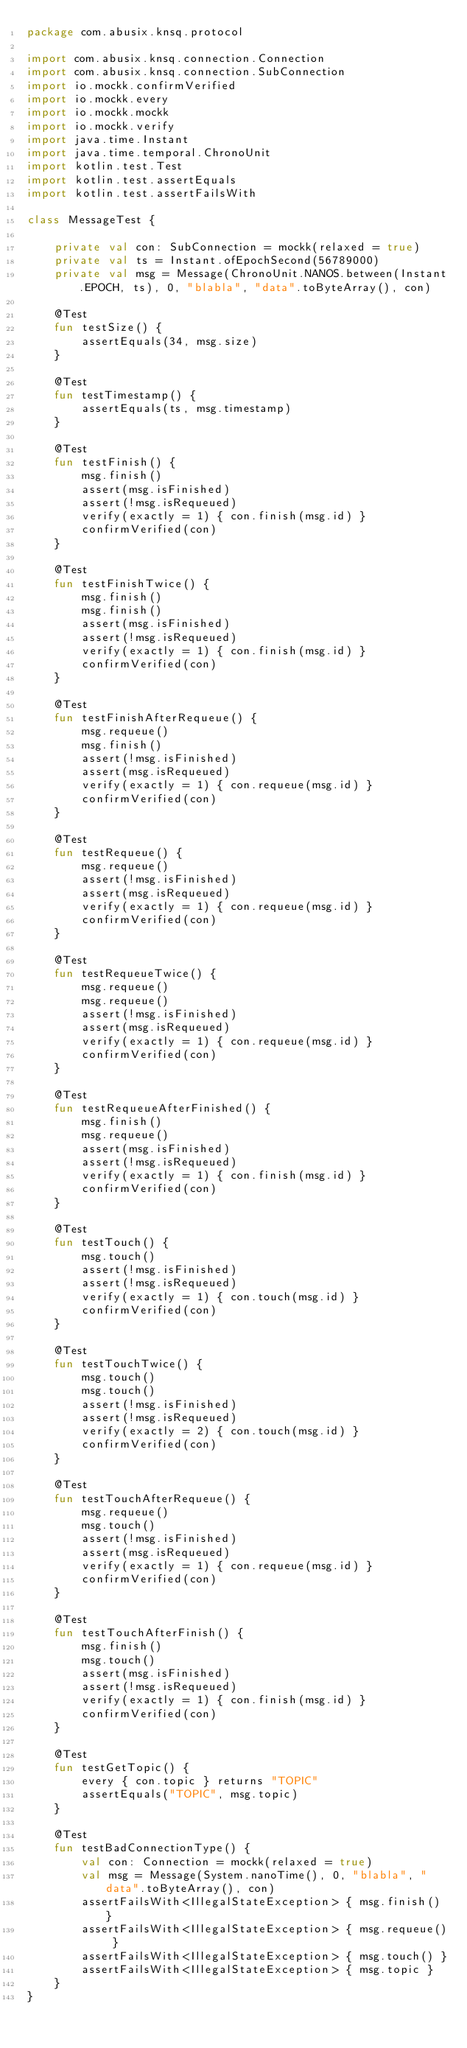Convert code to text. <code><loc_0><loc_0><loc_500><loc_500><_Kotlin_>package com.abusix.knsq.protocol

import com.abusix.knsq.connection.Connection
import com.abusix.knsq.connection.SubConnection
import io.mockk.confirmVerified
import io.mockk.every
import io.mockk.mockk
import io.mockk.verify
import java.time.Instant
import java.time.temporal.ChronoUnit
import kotlin.test.Test
import kotlin.test.assertEquals
import kotlin.test.assertFailsWith

class MessageTest {

    private val con: SubConnection = mockk(relaxed = true)
    private val ts = Instant.ofEpochSecond(56789000)
    private val msg = Message(ChronoUnit.NANOS.between(Instant.EPOCH, ts), 0, "blabla", "data".toByteArray(), con)

    @Test
    fun testSize() {
        assertEquals(34, msg.size)
    }

    @Test
    fun testTimestamp() {
        assertEquals(ts, msg.timestamp)
    }

    @Test
    fun testFinish() {
        msg.finish()
        assert(msg.isFinished)
        assert(!msg.isRequeued)
        verify(exactly = 1) { con.finish(msg.id) }
        confirmVerified(con)
    }

    @Test
    fun testFinishTwice() {
        msg.finish()
        msg.finish()
        assert(msg.isFinished)
        assert(!msg.isRequeued)
        verify(exactly = 1) { con.finish(msg.id) }
        confirmVerified(con)
    }

    @Test
    fun testFinishAfterRequeue() {
        msg.requeue()
        msg.finish()
        assert(!msg.isFinished)
        assert(msg.isRequeued)
        verify(exactly = 1) { con.requeue(msg.id) }
        confirmVerified(con)
    }

    @Test
    fun testRequeue() {
        msg.requeue()
        assert(!msg.isFinished)
        assert(msg.isRequeued)
        verify(exactly = 1) { con.requeue(msg.id) }
        confirmVerified(con)
    }

    @Test
    fun testRequeueTwice() {
        msg.requeue()
        msg.requeue()
        assert(!msg.isFinished)
        assert(msg.isRequeued)
        verify(exactly = 1) { con.requeue(msg.id) }
        confirmVerified(con)
    }

    @Test
    fun testRequeueAfterFinished() {
        msg.finish()
        msg.requeue()
        assert(msg.isFinished)
        assert(!msg.isRequeued)
        verify(exactly = 1) { con.finish(msg.id) }
        confirmVerified(con)
    }

    @Test
    fun testTouch() {
        msg.touch()
        assert(!msg.isFinished)
        assert(!msg.isRequeued)
        verify(exactly = 1) { con.touch(msg.id) }
        confirmVerified(con)
    }

    @Test
    fun testTouchTwice() {
        msg.touch()
        msg.touch()
        assert(!msg.isFinished)
        assert(!msg.isRequeued)
        verify(exactly = 2) { con.touch(msg.id) }
        confirmVerified(con)
    }

    @Test
    fun testTouchAfterRequeue() {
        msg.requeue()
        msg.touch()
        assert(!msg.isFinished)
        assert(msg.isRequeued)
        verify(exactly = 1) { con.requeue(msg.id) }
        confirmVerified(con)
    }

    @Test
    fun testTouchAfterFinish() {
        msg.finish()
        msg.touch()
        assert(msg.isFinished)
        assert(!msg.isRequeued)
        verify(exactly = 1) { con.finish(msg.id) }
        confirmVerified(con)
    }

    @Test
    fun testGetTopic() {
        every { con.topic } returns "TOPIC"
        assertEquals("TOPIC", msg.topic)
    }

    @Test
    fun testBadConnectionType() {
        val con: Connection = mockk(relaxed = true)
        val msg = Message(System.nanoTime(), 0, "blabla", "data".toByteArray(), con)
        assertFailsWith<IllegalStateException> { msg.finish() }
        assertFailsWith<IllegalStateException> { msg.requeue() }
        assertFailsWith<IllegalStateException> { msg.touch() }
        assertFailsWith<IllegalStateException> { msg.topic }
    }
}</code> 